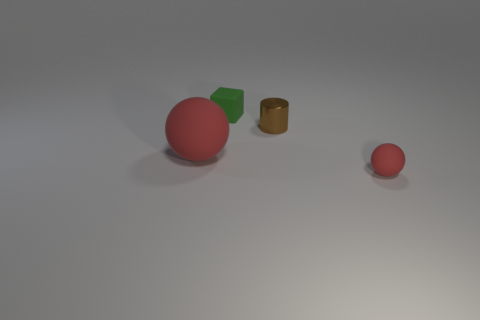Subtract all brown balls. Subtract all red blocks. How many balls are left? 2 Add 2 small cylinders. How many objects exist? 6 Subtract all cylinders. How many objects are left? 3 Add 3 gray metallic objects. How many gray metallic objects exist? 3 Subtract 1 green blocks. How many objects are left? 3 Subtract all green matte things. Subtract all green matte objects. How many objects are left? 2 Add 3 metallic things. How many metallic things are left? 4 